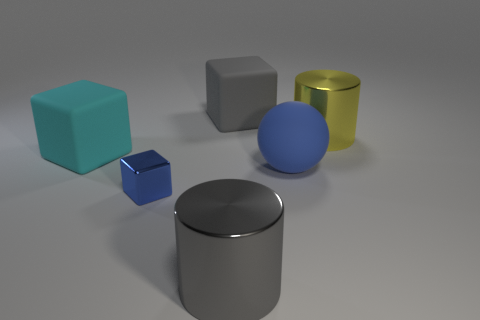Add 1 tiny blue metallic cubes. How many objects exist? 7 Subtract all cylinders. How many objects are left? 4 Subtract 0 purple blocks. How many objects are left? 6 Subtract all blue matte spheres. Subtract all large gray rubber blocks. How many objects are left? 4 Add 1 yellow metal things. How many yellow metal things are left? 2 Add 1 red shiny things. How many red shiny things exist? 1 